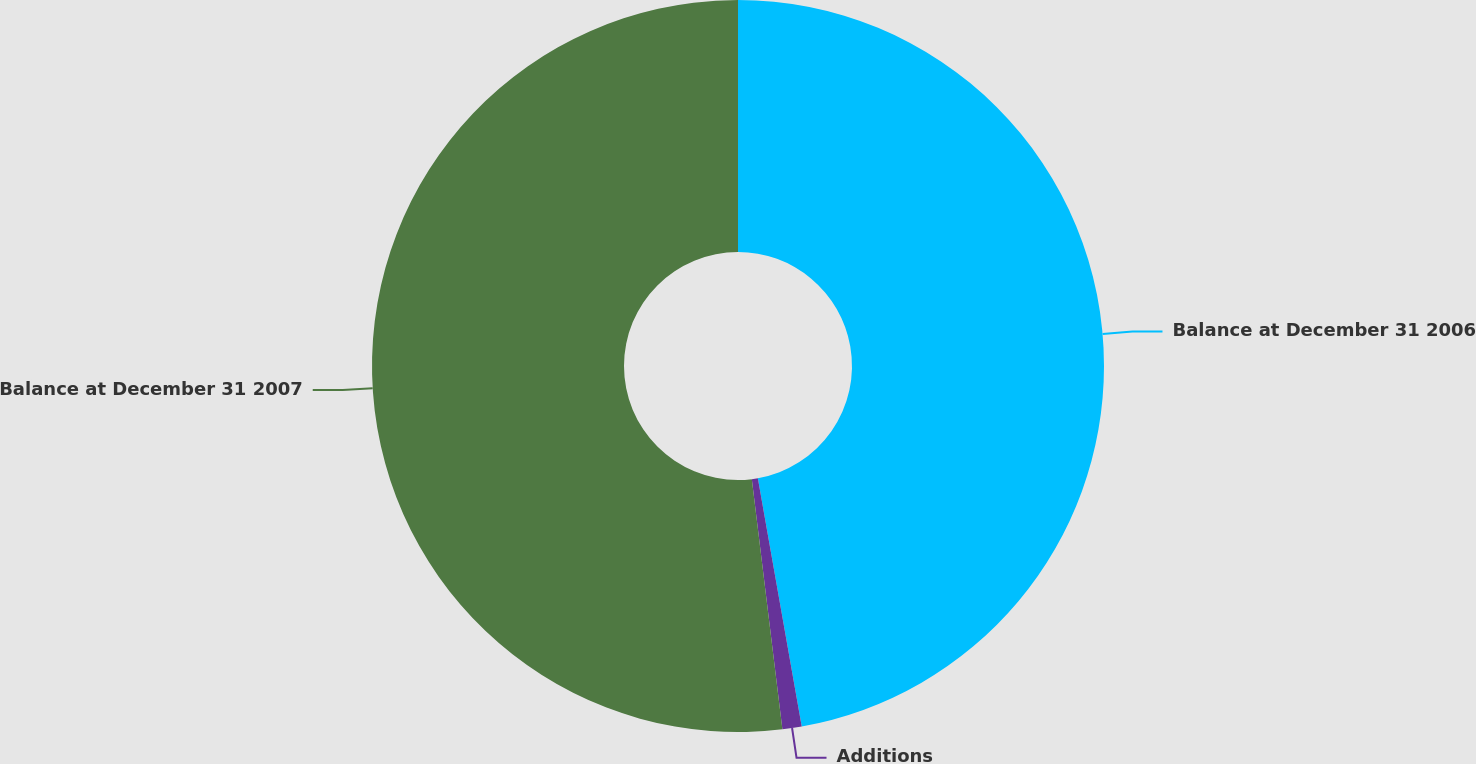Convert chart. <chart><loc_0><loc_0><loc_500><loc_500><pie_chart><fcel>Balance at December 31 2006<fcel>Additions<fcel>Balance at December 31 2007<nl><fcel>47.21%<fcel>0.85%<fcel>51.93%<nl></chart> 